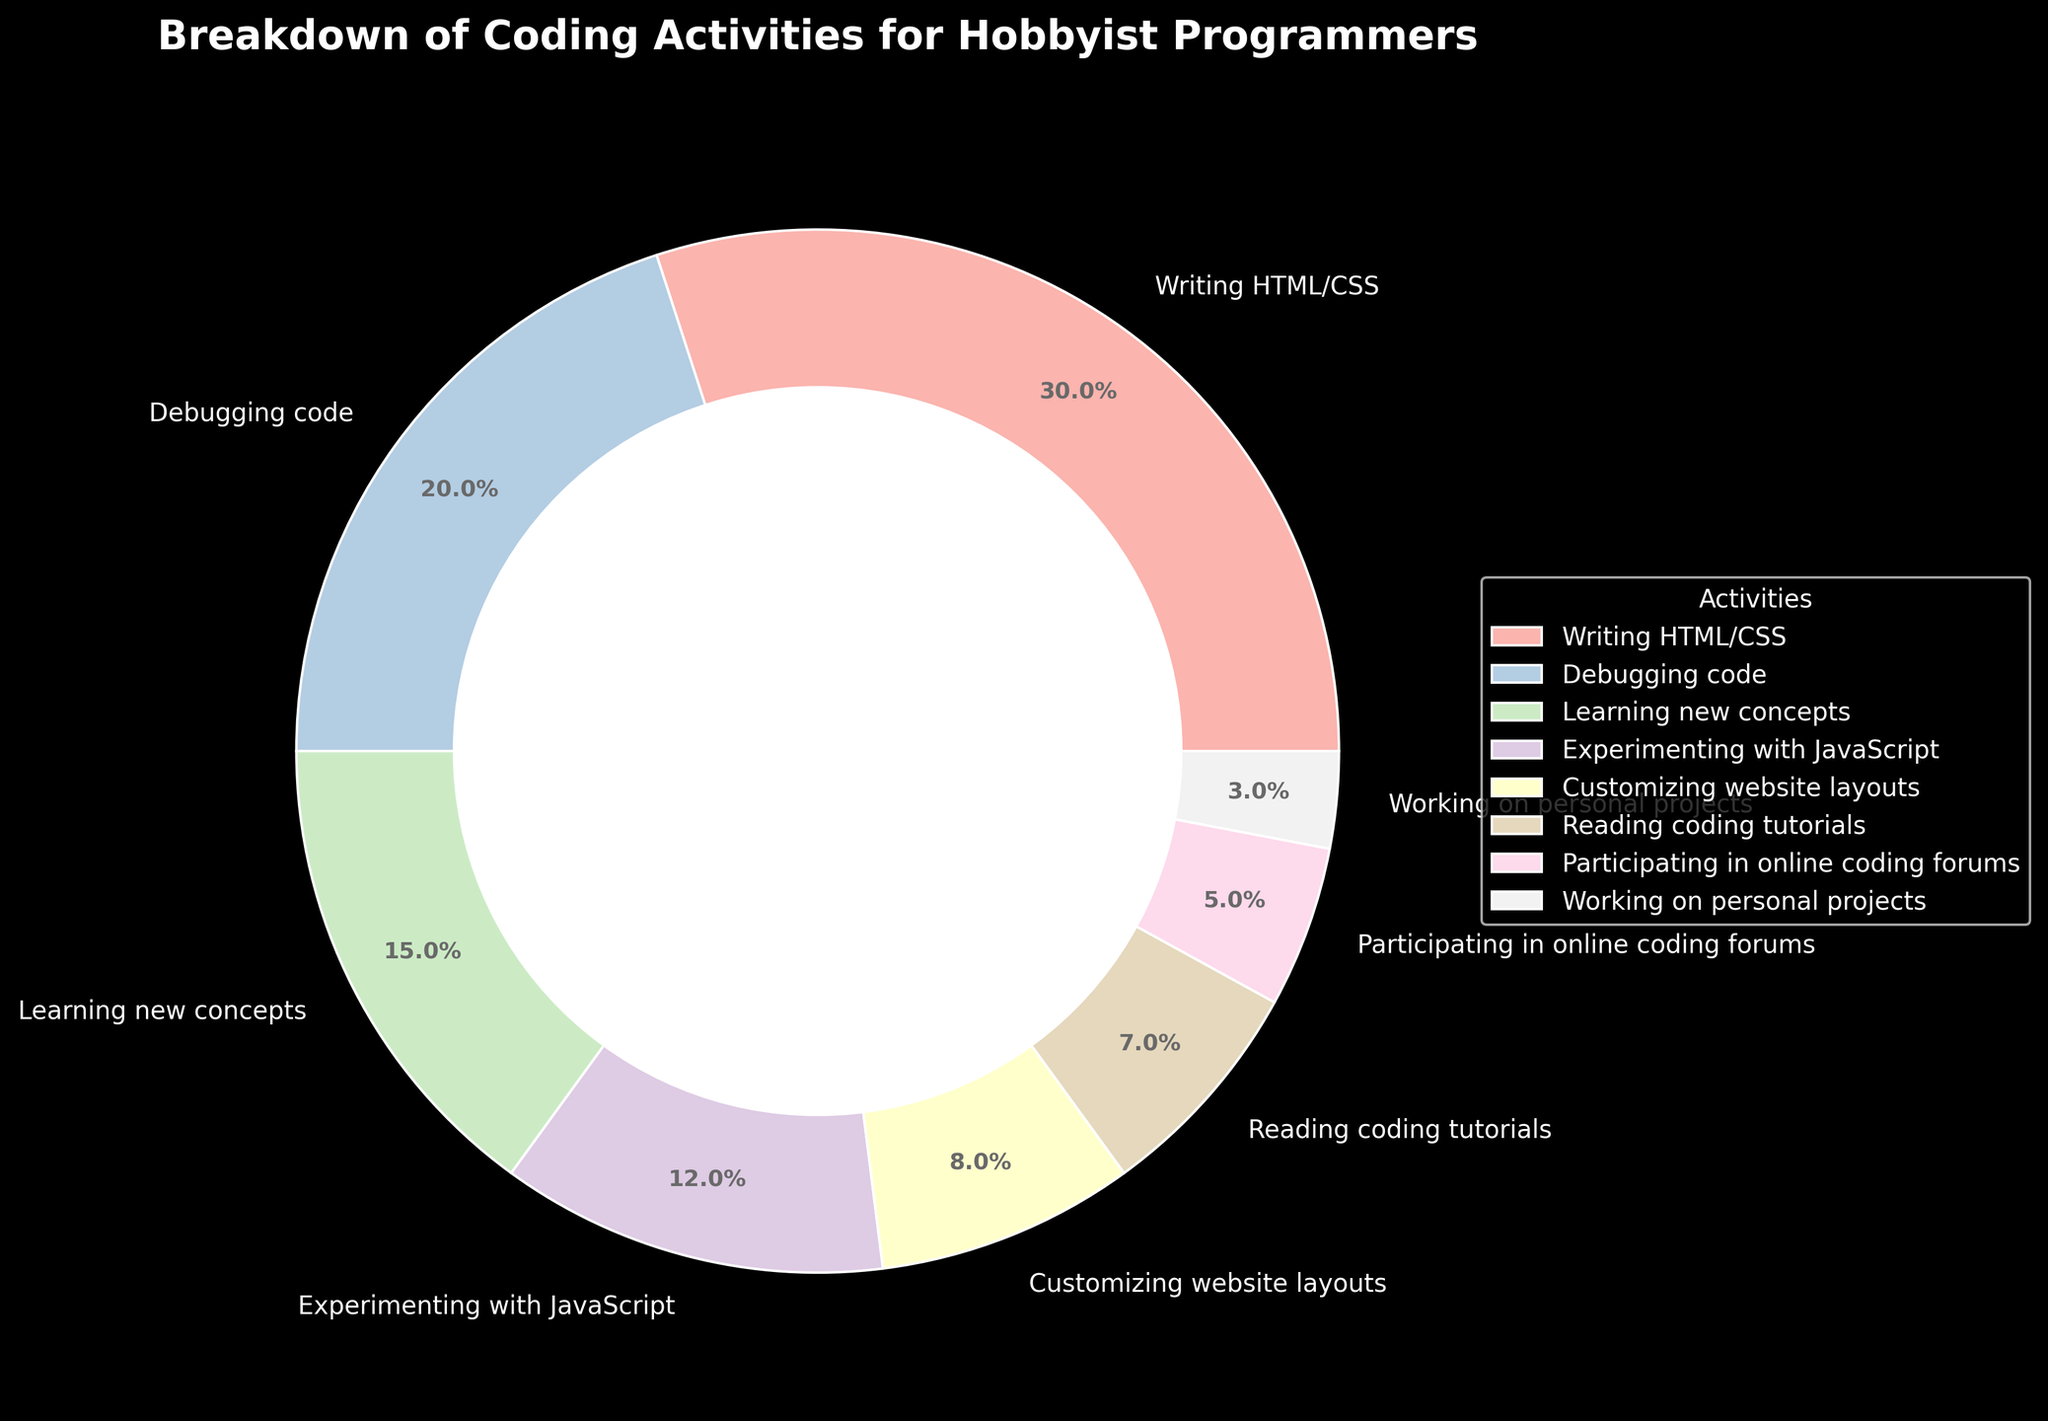What is the percentage of time spent writing HTML/CSS? The figure shows that the section labeled "Writing HTML/CSS" accounts for 30% of the pie chart.
Answer: 30% What is the combined percentage of time spent on debugging code and reading coding tutorials? According to the figure, debugging code takes 20% of the time, and reading coding tutorials takes 7%. Adding these two values together gives 20% + 7% = 27%.
Answer: 27% Which activity takes up the least amount of time according to the chart? The section labeled "Working on personal projects" occupies the smallest portion of the pie, indicating it takes the least amount of time at 3%.
Answer: Working on personal projects How much more time is spent on writing HTML/CSS compared to experimenting with JavaScript? The figure shows writing HTML/CSS uses 30% of the time, while experimenting with JavaScript takes 12%. The difference is 30% - 12% = 18%.
Answer: 18% Is more time spent on participating in online coding forums or customizing website layouts? According to the figure, participating in online coding forums accounts for 5%, whereas customizing website layouts accounts for 8%. Therefore, more time is spent on customizing website layouts.
Answer: Customizing website layouts How does the time spent learning new concepts compare to the time spent reading coding tutorials? The chart indicates that learning new concepts takes 15% of the time, whereas reading coding tutorials takes 7%. Since 15% is greater than 7%, more time is spent learning new concepts.
Answer: Learning new concepts What is the total percentage of time spent on activities besides writing HTML/CSS? The percentage of time spent on writing HTML/CSS is 30%. To find the percentage of time spent on all other activities, subtract 30% from 100%, which is 100% - 30% = 70%.
Answer: 70% What is two times the percentage of time spent on participating in online coding forums? The figure indicates that 5% of the time is spent participating in online coding forums. Doubling this value results in 2 * 5% = 10%.
Answer: 10% Which activity is represented by the section with the second largest portion of the pie chart? The largest portion corresponds to writing HTML/CSS at 30%. The second largest section is debugging code, which represents 20% of the pie.
Answer: Debugging code 